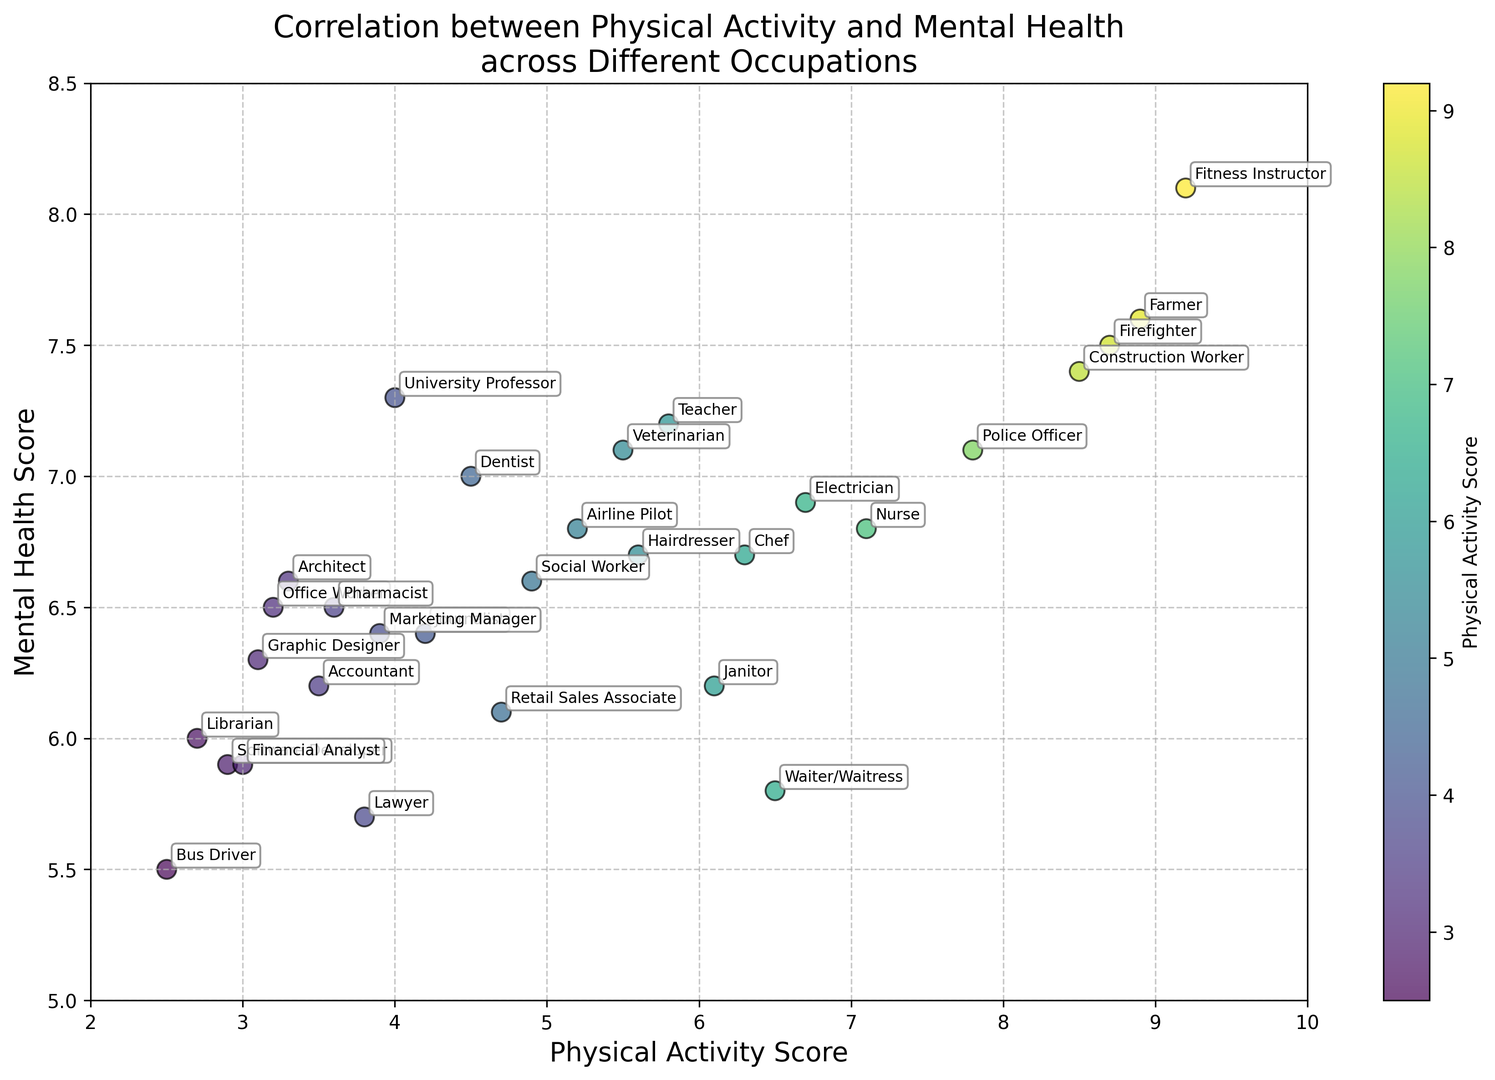Which occupation has the highest physical activity score? By examining the scatter plot, look for the label associated with the highest value on the x-axis. Fitness Instructor is positioned at the highest value on the x-axis.
Answer: Fitness Instructor Which occupations have nearly the same mental health scores but different physical activity scores? Compare the y-axis values and find clusters with similar y-values but spread along the x-axis. Teacher and University Professor both have similar mental health scores around 7.3 but different physical activity scores of 5.8 and 4.0, respectively.
Answer: Teacher and University Professor How does the mental health score of a Software Developer compare to that of a Police Officer? Locate both occupations on the scatter plot and compare their y-axis positions. The Software Developer has a mental health score of 5.9, which is lower than the Police Officer's score of 7.1.
Answer: Police Officer has a higher score What is the difference in physical activity scores between a Lawyer and a Construction Worker? Locate both occupations on the x-axis and subtract the smaller value from the larger one. Lawyer has a score of 3.8, and Construction Worker has a score of 8.5, resulting in a difference of 4.7.
Answer: 4.7 Which occupation has the highest mental health score and what is its physical activity score? Find the label with the highest y-axis value and check its corresponding x-axis value. Fitness Instructor has the highest mental health score of 8.1 and a physical activity score of 9.2.
Answer: Fitness Instructor, 9.2 What is the average mental health score for the occupations with physical activity scores above 7.0? Identify the occupations with physical activity scores above 7.0 and calculate their average mental health score. These occupations are Nurse (6.8), Construction Worker (7.4), Police Officer (7.1), Farmer (7.6), Fitness Instructor (8.1), and Firefighter (7.5). The average is (6.8 + 7.4 + 7.1 + 7.6 + 8.1 + 7.5) / 6 = 7.42.
Answer: 7.42 Between which two occupations is the difference in mental health scores the largest? Look for the two occupations that have the greatest vertical distance between them. Fitness Instructor (8.1) and Bus Driver (5.5) have the largest difference in mental health scores, which is 8.1 - 5.5 = 2.6.
Answer: Fitness Instructor and Bus Driver 